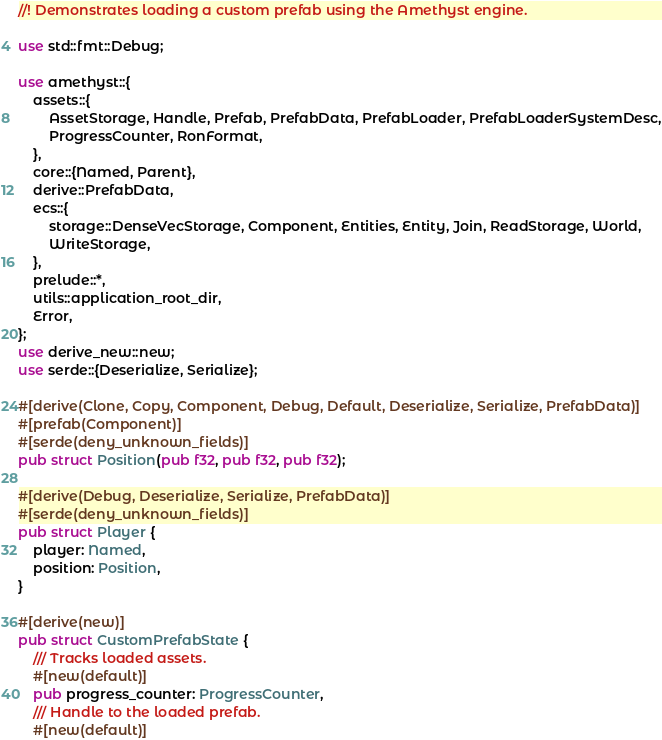<code> <loc_0><loc_0><loc_500><loc_500><_Rust_>//! Demonstrates loading a custom prefab using the Amethyst engine.

use std::fmt::Debug;

use amethyst::{
    assets::{
        AssetStorage, Handle, Prefab, PrefabData, PrefabLoader, PrefabLoaderSystemDesc,
        ProgressCounter, RonFormat,
    },
    core::{Named, Parent},
    derive::PrefabData,
    ecs::{
        storage::DenseVecStorage, Component, Entities, Entity, Join, ReadStorage, World,
        WriteStorage,
    },
    prelude::*,
    utils::application_root_dir,
    Error,
};
use derive_new::new;
use serde::{Deserialize, Serialize};

#[derive(Clone, Copy, Component, Debug, Default, Deserialize, Serialize, PrefabData)]
#[prefab(Component)]
#[serde(deny_unknown_fields)]
pub struct Position(pub f32, pub f32, pub f32);

#[derive(Debug, Deserialize, Serialize, PrefabData)]
#[serde(deny_unknown_fields)]
pub struct Player {
    player: Named,
    position: Position,
}

#[derive(new)]
pub struct CustomPrefabState {
    /// Tracks loaded assets.
    #[new(default)]
    pub progress_counter: ProgressCounter,
    /// Handle to the loaded prefab.
    #[new(default)]</code> 